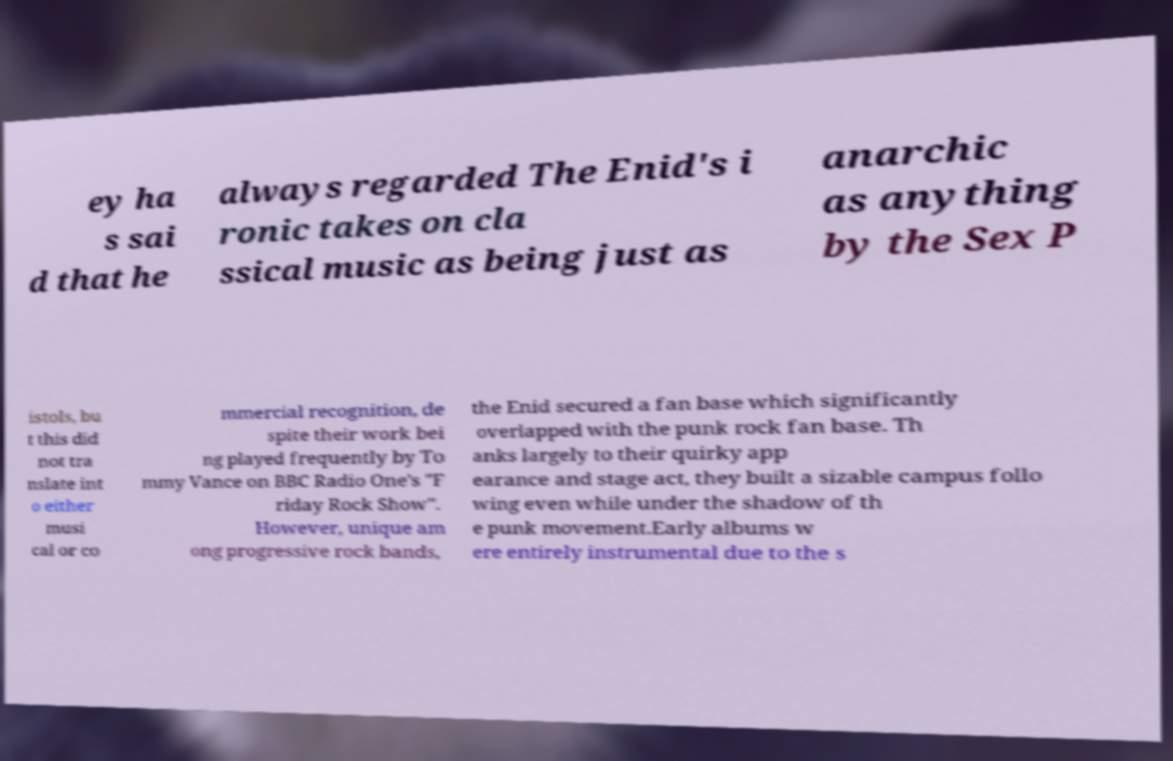Could you assist in decoding the text presented in this image and type it out clearly? ey ha s sai d that he always regarded The Enid's i ronic takes on cla ssical music as being just as anarchic as anything by the Sex P istols, bu t this did not tra nslate int o either musi cal or co mmercial recognition, de spite their work bei ng played frequently by To mmy Vance on BBC Radio One's "F riday Rock Show". However, unique am ong progressive rock bands, the Enid secured a fan base which significantly overlapped with the punk rock fan base. Th anks largely to their quirky app earance and stage act, they built a sizable campus follo wing even while under the shadow of th e punk movement.Early albums w ere entirely instrumental due to the s 